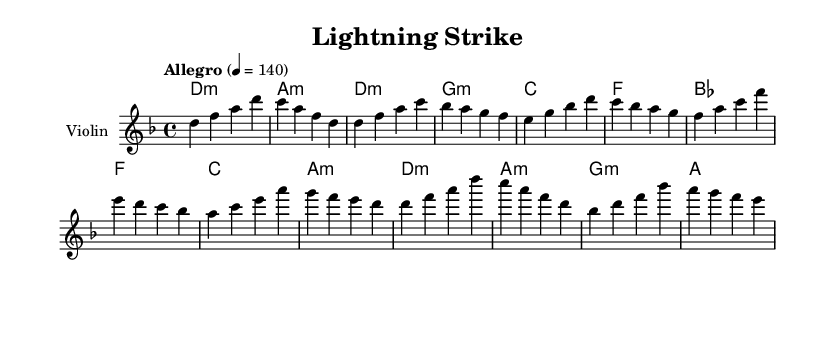What is the key signature of this music? The key signature is D minor, which has one flat (B flat). This can be identified at the beginning of the staff where the sharp or flat signs are located.
Answer: D minor What is the time signature of this music? The time signature is 4/4, which indicates that there are four beats per measure and a quarter note receives one beat. This is found at the beginning of the music, near the key signature.
Answer: 4/4 What is the tempo marking of this piece? The tempo marking is Allegro, which indicates a fast and lively pace. The metronome marking shows it at 140 beats per minute, giving the performer guidance on how quickly to play the piece. This information is typically placed near the beginning of the score.
Answer: Allegro 4 = 140 How many measures are in the chorus section? The chorus section contains four measures. By counting the measures in the section labeled "Chorus" in the sheet music, we see that there are four distinct measures outlined for that part of the piece.
Answer: 4 What chord follows the first measure of the pre-chorus? The chord following the first measure of the pre-chorus is F major. This can be seen in the chord mode section where it is indicated directly after the measure in question.
Answer: F What instrument is this piece written for? This piece is written for the violin, which is clearly labeled at the beginning of the staff along with the corresponding MIDI instrument.
Answer: Violin Which section has a contrasting dynamic compared to the verse? The pre-chorus has a contrasting dynamic to the verse, where the musical phrases and harmonies differ. Analyzing the phrases, the pre-chorus builds tension, making it quite different from the verse sections.
Answer: Pre-chorus 